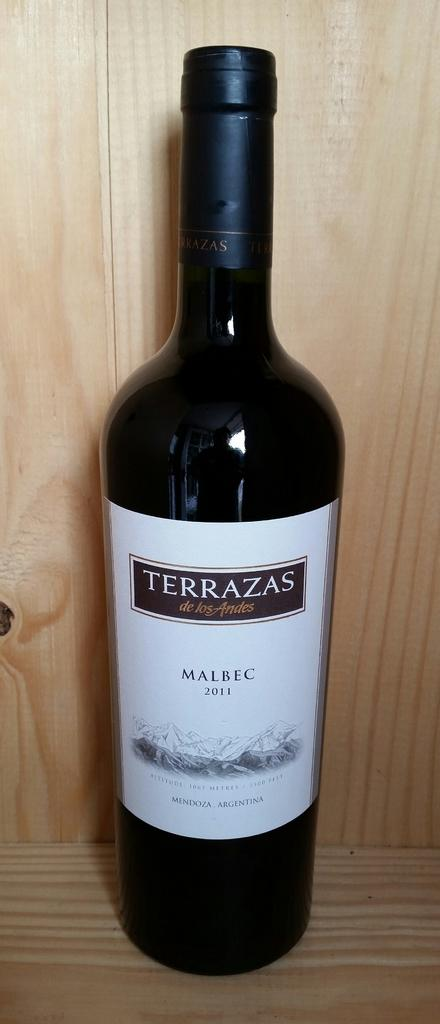<image>
Give a short and clear explanation of the subsequent image. A bottle of 2011 Malbec stands on a wood shelf. 